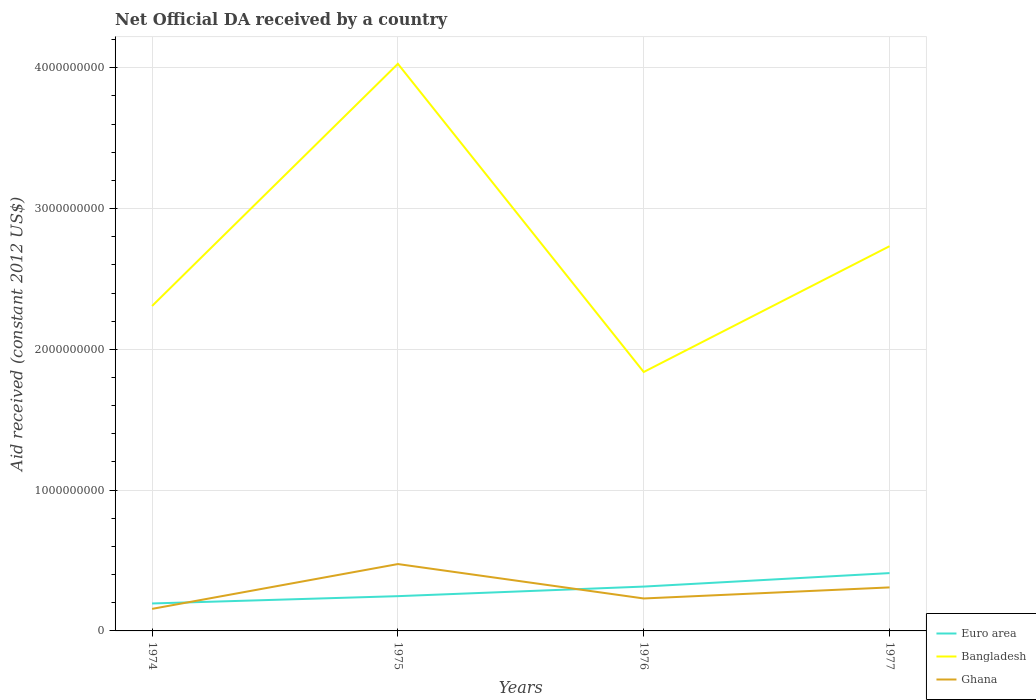Does the line corresponding to Bangladesh intersect with the line corresponding to Ghana?
Provide a succinct answer. No. Is the number of lines equal to the number of legend labels?
Ensure brevity in your answer.  Yes. Across all years, what is the maximum net official development assistance aid received in Bangladesh?
Provide a succinct answer. 1.84e+09. In which year was the net official development assistance aid received in Ghana maximum?
Keep it short and to the point. 1974. What is the total net official development assistance aid received in Ghana in the graph?
Your answer should be very brief. -7.38e+07. What is the difference between the highest and the second highest net official development assistance aid received in Bangladesh?
Your response must be concise. 2.19e+09. What is the difference between the highest and the lowest net official development assistance aid received in Euro area?
Provide a short and direct response. 2. How many lines are there?
Offer a very short reply. 3. How many years are there in the graph?
Make the answer very short. 4. Where does the legend appear in the graph?
Your answer should be very brief. Bottom right. How are the legend labels stacked?
Provide a short and direct response. Vertical. What is the title of the graph?
Give a very brief answer. Net Official DA received by a country. What is the label or title of the X-axis?
Your response must be concise. Years. What is the label or title of the Y-axis?
Offer a very short reply. Aid received (constant 2012 US$). What is the Aid received (constant 2012 US$) in Euro area in 1974?
Provide a short and direct response. 1.95e+08. What is the Aid received (constant 2012 US$) of Bangladesh in 1974?
Offer a terse response. 2.31e+09. What is the Aid received (constant 2012 US$) of Ghana in 1974?
Provide a short and direct response. 1.57e+08. What is the Aid received (constant 2012 US$) of Euro area in 1975?
Make the answer very short. 2.47e+08. What is the Aid received (constant 2012 US$) of Bangladesh in 1975?
Provide a succinct answer. 4.03e+09. What is the Aid received (constant 2012 US$) of Ghana in 1975?
Give a very brief answer. 4.75e+08. What is the Aid received (constant 2012 US$) of Euro area in 1976?
Your answer should be compact. 3.15e+08. What is the Aid received (constant 2012 US$) of Bangladesh in 1976?
Your answer should be compact. 1.84e+09. What is the Aid received (constant 2012 US$) in Ghana in 1976?
Ensure brevity in your answer.  2.30e+08. What is the Aid received (constant 2012 US$) of Euro area in 1977?
Ensure brevity in your answer.  4.11e+08. What is the Aid received (constant 2012 US$) of Bangladesh in 1977?
Your answer should be compact. 2.73e+09. What is the Aid received (constant 2012 US$) of Ghana in 1977?
Provide a short and direct response. 3.09e+08. Across all years, what is the maximum Aid received (constant 2012 US$) in Euro area?
Your answer should be very brief. 4.11e+08. Across all years, what is the maximum Aid received (constant 2012 US$) of Bangladesh?
Offer a very short reply. 4.03e+09. Across all years, what is the maximum Aid received (constant 2012 US$) of Ghana?
Provide a succinct answer. 4.75e+08. Across all years, what is the minimum Aid received (constant 2012 US$) of Euro area?
Offer a very short reply. 1.95e+08. Across all years, what is the minimum Aid received (constant 2012 US$) of Bangladesh?
Your response must be concise. 1.84e+09. Across all years, what is the minimum Aid received (constant 2012 US$) of Ghana?
Keep it short and to the point. 1.57e+08. What is the total Aid received (constant 2012 US$) in Euro area in the graph?
Your response must be concise. 1.17e+09. What is the total Aid received (constant 2012 US$) in Bangladesh in the graph?
Provide a succinct answer. 1.09e+1. What is the total Aid received (constant 2012 US$) in Ghana in the graph?
Provide a succinct answer. 1.17e+09. What is the difference between the Aid received (constant 2012 US$) in Euro area in 1974 and that in 1975?
Provide a succinct answer. -5.19e+07. What is the difference between the Aid received (constant 2012 US$) in Bangladesh in 1974 and that in 1975?
Make the answer very short. -1.72e+09. What is the difference between the Aid received (constant 2012 US$) of Ghana in 1974 and that in 1975?
Give a very brief answer. -3.18e+08. What is the difference between the Aid received (constant 2012 US$) of Euro area in 1974 and that in 1976?
Offer a terse response. -1.20e+08. What is the difference between the Aid received (constant 2012 US$) in Bangladesh in 1974 and that in 1976?
Provide a short and direct response. 4.69e+08. What is the difference between the Aid received (constant 2012 US$) in Ghana in 1974 and that in 1976?
Keep it short and to the point. -7.38e+07. What is the difference between the Aid received (constant 2012 US$) in Euro area in 1974 and that in 1977?
Keep it short and to the point. -2.16e+08. What is the difference between the Aid received (constant 2012 US$) of Bangladesh in 1974 and that in 1977?
Make the answer very short. -4.25e+08. What is the difference between the Aid received (constant 2012 US$) of Ghana in 1974 and that in 1977?
Your answer should be very brief. -1.52e+08. What is the difference between the Aid received (constant 2012 US$) of Euro area in 1975 and that in 1976?
Your answer should be compact. -6.81e+07. What is the difference between the Aid received (constant 2012 US$) in Bangladesh in 1975 and that in 1976?
Your answer should be compact. 2.19e+09. What is the difference between the Aid received (constant 2012 US$) of Ghana in 1975 and that in 1976?
Provide a succinct answer. 2.44e+08. What is the difference between the Aid received (constant 2012 US$) in Euro area in 1975 and that in 1977?
Give a very brief answer. -1.64e+08. What is the difference between the Aid received (constant 2012 US$) of Bangladesh in 1975 and that in 1977?
Make the answer very short. 1.30e+09. What is the difference between the Aid received (constant 2012 US$) of Ghana in 1975 and that in 1977?
Make the answer very short. 1.66e+08. What is the difference between the Aid received (constant 2012 US$) in Euro area in 1976 and that in 1977?
Your response must be concise. -9.58e+07. What is the difference between the Aid received (constant 2012 US$) of Bangladesh in 1976 and that in 1977?
Provide a short and direct response. -8.94e+08. What is the difference between the Aid received (constant 2012 US$) in Ghana in 1976 and that in 1977?
Give a very brief answer. -7.86e+07. What is the difference between the Aid received (constant 2012 US$) of Euro area in 1974 and the Aid received (constant 2012 US$) of Bangladesh in 1975?
Provide a succinct answer. -3.83e+09. What is the difference between the Aid received (constant 2012 US$) in Euro area in 1974 and the Aid received (constant 2012 US$) in Ghana in 1975?
Provide a short and direct response. -2.80e+08. What is the difference between the Aid received (constant 2012 US$) of Bangladesh in 1974 and the Aid received (constant 2012 US$) of Ghana in 1975?
Your response must be concise. 1.83e+09. What is the difference between the Aid received (constant 2012 US$) of Euro area in 1974 and the Aid received (constant 2012 US$) of Bangladesh in 1976?
Offer a terse response. -1.64e+09. What is the difference between the Aid received (constant 2012 US$) of Euro area in 1974 and the Aid received (constant 2012 US$) of Ghana in 1976?
Ensure brevity in your answer.  -3.55e+07. What is the difference between the Aid received (constant 2012 US$) of Bangladesh in 1974 and the Aid received (constant 2012 US$) of Ghana in 1976?
Your answer should be very brief. 2.08e+09. What is the difference between the Aid received (constant 2012 US$) of Euro area in 1974 and the Aid received (constant 2012 US$) of Bangladesh in 1977?
Offer a very short reply. -2.54e+09. What is the difference between the Aid received (constant 2012 US$) in Euro area in 1974 and the Aid received (constant 2012 US$) in Ghana in 1977?
Offer a terse response. -1.14e+08. What is the difference between the Aid received (constant 2012 US$) of Bangladesh in 1974 and the Aid received (constant 2012 US$) of Ghana in 1977?
Your answer should be very brief. 2.00e+09. What is the difference between the Aid received (constant 2012 US$) in Euro area in 1975 and the Aid received (constant 2012 US$) in Bangladesh in 1976?
Offer a very short reply. -1.59e+09. What is the difference between the Aid received (constant 2012 US$) in Euro area in 1975 and the Aid received (constant 2012 US$) in Ghana in 1976?
Your answer should be very brief. 1.64e+07. What is the difference between the Aid received (constant 2012 US$) of Bangladesh in 1975 and the Aid received (constant 2012 US$) of Ghana in 1976?
Ensure brevity in your answer.  3.80e+09. What is the difference between the Aid received (constant 2012 US$) in Euro area in 1975 and the Aid received (constant 2012 US$) in Bangladesh in 1977?
Provide a succinct answer. -2.49e+09. What is the difference between the Aid received (constant 2012 US$) in Euro area in 1975 and the Aid received (constant 2012 US$) in Ghana in 1977?
Provide a succinct answer. -6.22e+07. What is the difference between the Aid received (constant 2012 US$) of Bangladesh in 1975 and the Aid received (constant 2012 US$) of Ghana in 1977?
Keep it short and to the point. 3.72e+09. What is the difference between the Aid received (constant 2012 US$) of Euro area in 1976 and the Aid received (constant 2012 US$) of Bangladesh in 1977?
Offer a terse response. -2.42e+09. What is the difference between the Aid received (constant 2012 US$) of Euro area in 1976 and the Aid received (constant 2012 US$) of Ghana in 1977?
Your response must be concise. 5.88e+06. What is the difference between the Aid received (constant 2012 US$) in Bangladesh in 1976 and the Aid received (constant 2012 US$) in Ghana in 1977?
Offer a very short reply. 1.53e+09. What is the average Aid received (constant 2012 US$) of Euro area per year?
Your answer should be compact. 2.92e+08. What is the average Aid received (constant 2012 US$) in Bangladesh per year?
Offer a very short reply. 2.73e+09. What is the average Aid received (constant 2012 US$) in Ghana per year?
Keep it short and to the point. 2.93e+08. In the year 1974, what is the difference between the Aid received (constant 2012 US$) in Euro area and Aid received (constant 2012 US$) in Bangladesh?
Your answer should be very brief. -2.11e+09. In the year 1974, what is the difference between the Aid received (constant 2012 US$) of Euro area and Aid received (constant 2012 US$) of Ghana?
Provide a succinct answer. 3.84e+07. In the year 1974, what is the difference between the Aid received (constant 2012 US$) of Bangladesh and Aid received (constant 2012 US$) of Ghana?
Your answer should be compact. 2.15e+09. In the year 1975, what is the difference between the Aid received (constant 2012 US$) in Euro area and Aid received (constant 2012 US$) in Bangladesh?
Give a very brief answer. -3.78e+09. In the year 1975, what is the difference between the Aid received (constant 2012 US$) of Euro area and Aid received (constant 2012 US$) of Ghana?
Provide a short and direct response. -2.28e+08. In the year 1975, what is the difference between the Aid received (constant 2012 US$) of Bangladesh and Aid received (constant 2012 US$) of Ghana?
Provide a short and direct response. 3.55e+09. In the year 1976, what is the difference between the Aid received (constant 2012 US$) in Euro area and Aid received (constant 2012 US$) in Bangladesh?
Provide a succinct answer. -1.52e+09. In the year 1976, what is the difference between the Aid received (constant 2012 US$) in Euro area and Aid received (constant 2012 US$) in Ghana?
Your answer should be compact. 8.45e+07. In the year 1976, what is the difference between the Aid received (constant 2012 US$) in Bangladesh and Aid received (constant 2012 US$) in Ghana?
Your answer should be very brief. 1.61e+09. In the year 1977, what is the difference between the Aid received (constant 2012 US$) of Euro area and Aid received (constant 2012 US$) of Bangladesh?
Provide a succinct answer. -2.32e+09. In the year 1977, what is the difference between the Aid received (constant 2012 US$) of Euro area and Aid received (constant 2012 US$) of Ghana?
Make the answer very short. 1.02e+08. In the year 1977, what is the difference between the Aid received (constant 2012 US$) of Bangladesh and Aid received (constant 2012 US$) of Ghana?
Provide a succinct answer. 2.42e+09. What is the ratio of the Aid received (constant 2012 US$) of Euro area in 1974 to that in 1975?
Keep it short and to the point. 0.79. What is the ratio of the Aid received (constant 2012 US$) of Bangladesh in 1974 to that in 1975?
Ensure brevity in your answer.  0.57. What is the ratio of the Aid received (constant 2012 US$) of Ghana in 1974 to that in 1975?
Offer a terse response. 0.33. What is the ratio of the Aid received (constant 2012 US$) of Euro area in 1974 to that in 1976?
Offer a terse response. 0.62. What is the ratio of the Aid received (constant 2012 US$) in Bangladesh in 1974 to that in 1976?
Your response must be concise. 1.25. What is the ratio of the Aid received (constant 2012 US$) of Ghana in 1974 to that in 1976?
Offer a terse response. 0.68. What is the ratio of the Aid received (constant 2012 US$) of Euro area in 1974 to that in 1977?
Give a very brief answer. 0.47. What is the ratio of the Aid received (constant 2012 US$) in Bangladesh in 1974 to that in 1977?
Your answer should be very brief. 0.84. What is the ratio of the Aid received (constant 2012 US$) of Ghana in 1974 to that in 1977?
Your answer should be very brief. 0.51. What is the ratio of the Aid received (constant 2012 US$) of Euro area in 1975 to that in 1976?
Give a very brief answer. 0.78. What is the ratio of the Aid received (constant 2012 US$) in Bangladesh in 1975 to that in 1976?
Provide a short and direct response. 2.19. What is the ratio of the Aid received (constant 2012 US$) of Ghana in 1975 to that in 1976?
Provide a short and direct response. 2.06. What is the ratio of the Aid received (constant 2012 US$) of Euro area in 1975 to that in 1977?
Your answer should be compact. 0.6. What is the ratio of the Aid received (constant 2012 US$) in Bangladesh in 1975 to that in 1977?
Provide a succinct answer. 1.47. What is the ratio of the Aid received (constant 2012 US$) of Ghana in 1975 to that in 1977?
Provide a short and direct response. 1.54. What is the ratio of the Aid received (constant 2012 US$) of Euro area in 1976 to that in 1977?
Offer a very short reply. 0.77. What is the ratio of the Aid received (constant 2012 US$) of Bangladesh in 1976 to that in 1977?
Your answer should be compact. 0.67. What is the ratio of the Aid received (constant 2012 US$) of Ghana in 1976 to that in 1977?
Provide a short and direct response. 0.75. What is the difference between the highest and the second highest Aid received (constant 2012 US$) of Euro area?
Ensure brevity in your answer.  9.58e+07. What is the difference between the highest and the second highest Aid received (constant 2012 US$) in Bangladesh?
Make the answer very short. 1.30e+09. What is the difference between the highest and the second highest Aid received (constant 2012 US$) of Ghana?
Provide a short and direct response. 1.66e+08. What is the difference between the highest and the lowest Aid received (constant 2012 US$) in Euro area?
Keep it short and to the point. 2.16e+08. What is the difference between the highest and the lowest Aid received (constant 2012 US$) of Bangladesh?
Make the answer very short. 2.19e+09. What is the difference between the highest and the lowest Aid received (constant 2012 US$) of Ghana?
Give a very brief answer. 3.18e+08. 